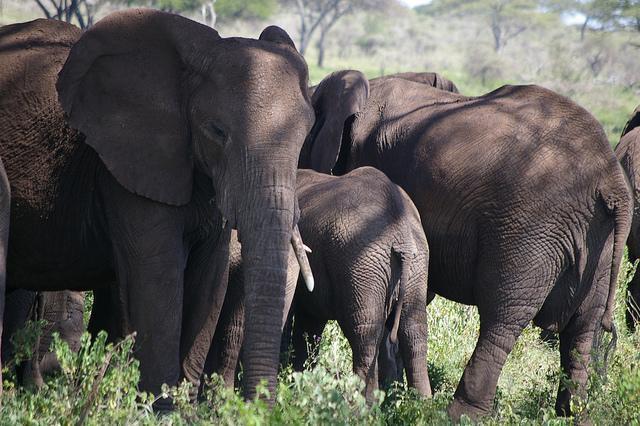How many animals?
Give a very brief answer. 4. How many elephants are pictured?
Give a very brief answer. 4. How many elephants are here?
Give a very brief answer. 4. How many elephants are in there?
Give a very brief answer. 3. How many elephant that is standing do you see?
Give a very brief answer. 4. How many elephants are there?
Give a very brief answer. 4. How many elephants can you see?
Give a very brief answer. 4. 